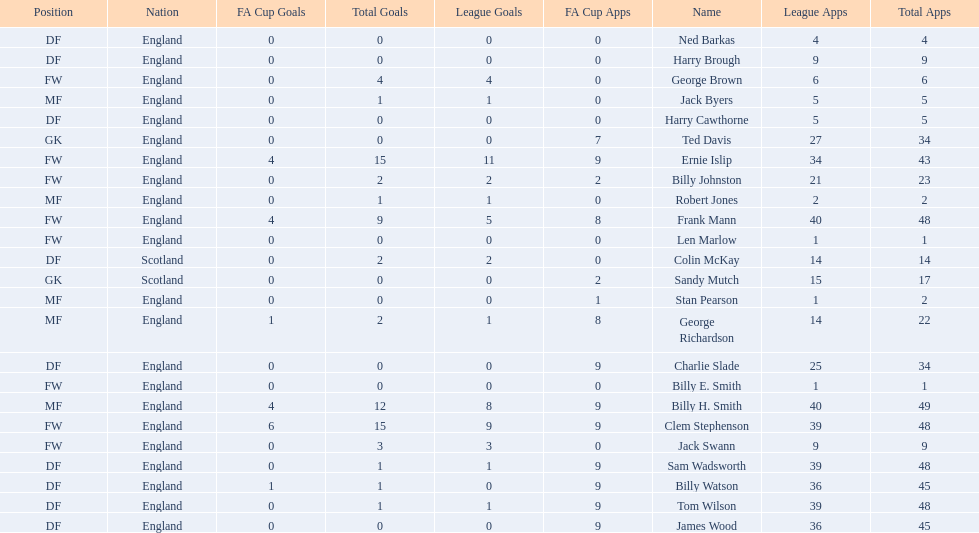The least number of total appearances 1. 